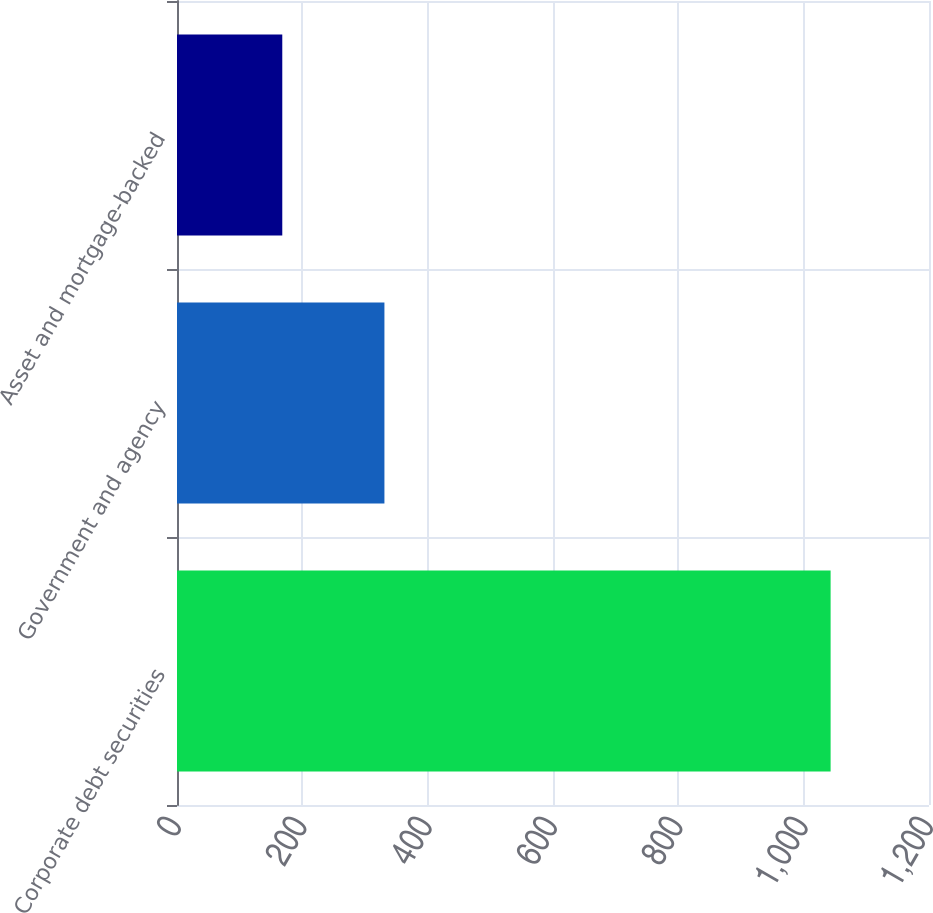Convert chart to OTSL. <chart><loc_0><loc_0><loc_500><loc_500><bar_chart><fcel>Corporate debt securities<fcel>Government and agency<fcel>Asset and mortgage-backed<nl><fcel>1043<fcel>331<fcel>168<nl></chart> 